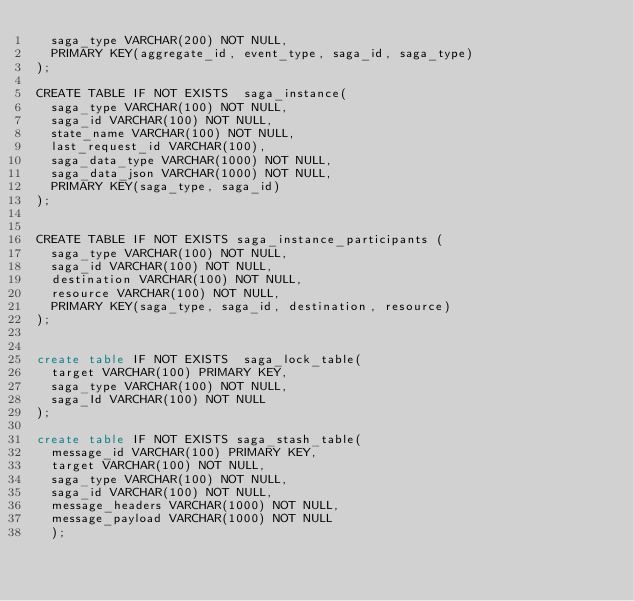Convert code to text. <code><loc_0><loc_0><loc_500><loc_500><_SQL_>  saga_type VARCHAR(200) NOT NULL,
  PRIMARY KEY(aggregate_id, event_type, saga_id, saga_type)
);

CREATE TABLE IF NOT EXISTS  saga_instance(
  saga_type VARCHAR(100) NOT NULL,
  saga_id VARCHAR(100) NOT NULL,
  state_name VARCHAR(100) NOT NULL,
  last_request_id VARCHAR(100),
  saga_data_type VARCHAR(1000) NOT NULL,
  saga_data_json VARCHAR(1000) NOT NULL,
  PRIMARY KEY(saga_type, saga_id)
);


CREATE TABLE IF NOT EXISTS saga_instance_participants (
  saga_type VARCHAR(100) NOT NULL,
  saga_id VARCHAR(100) NOT NULL,
  destination VARCHAR(100) NOT NULL,
  resource VARCHAR(100) NOT NULL,
  PRIMARY KEY(saga_type, saga_id, destination, resource)
);


create table IF NOT EXISTS  saga_lock_table(
  target VARCHAR(100) PRIMARY KEY,
  saga_type VARCHAR(100) NOT NULL,
  saga_Id VARCHAR(100) NOT NULL
);

create table IF NOT EXISTS saga_stash_table(
  message_id VARCHAR(100) PRIMARY KEY,
  target VARCHAR(100) NOT NULL,
  saga_type VARCHAR(100) NOT NULL,
  saga_id VARCHAR(100) NOT NULL,
  message_headers VARCHAR(1000) NOT NULL,
  message_payload VARCHAR(1000) NOT NULL
  );

</code> 